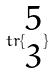<formula> <loc_0><loc_0><loc_500><loc_500>t r \{ \begin{matrix} 5 \\ 3 \end{matrix} \}</formula> 